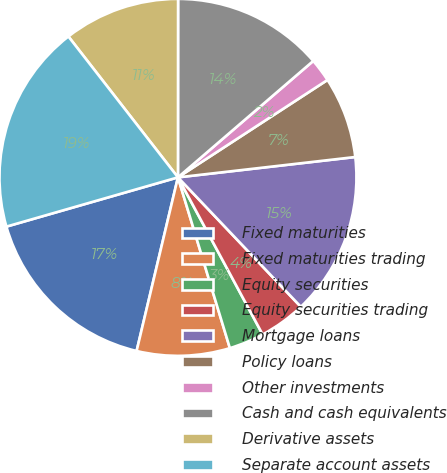<chart> <loc_0><loc_0><loc_500><loc_500><pie_chart><fcel>Fixed maturities<fcel>Fixed maturities trading<fcel>Equity securities<fcel>Equity securities trading<fcel>Mortgage loans<fcel>Policy loans<fcel>Other investments<fcel>Cash and cash equivalents<fcel>Derivative assets<fcel>Separate account assets<nl><fcel>16.83%<fcel>8.42%<fcel>3.17%<fcel>4.22%<fcel>14.73%<fcel>7.37%<fcel>2.12%<fcel>13.68%<fcel>10.53%<fcel>18.93%<nl></chart> 